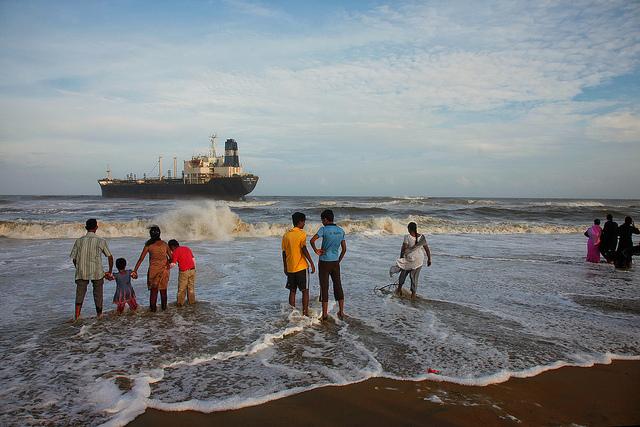How many cruise ships are there?
Be succinct. 1. What does the man in the blue shirt have in his hand?
Concise answer only. Nothing. Are there any clouds in the sky?
Give a very brief answer. Yes. Are they all looking at the ship?
Keep it brief. No. How many people are in the water?
Concise answer only. 10. Do the children seem to be enjoying themselves?
Short answer required. Yes. Are the people getting wet?
Write a very short answer. Yes. 